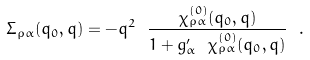Convert formula to latex. <formula><loc_0><loc_0><loc_500><loc_500>\Sigma _ { \rho \alpha } ( q _ { 0 } , q ) = - q ^ { 2 } \ \frac { \chi _ { \rho \alpha } ^ { ( 0 ) } ( q _ { 0 } , q ) } { 1 + g ^ { \prime } _ { \alpha } \ \chi _ { \rho \alpha } ^ { ( 0 ) } ( q _ { 0 } , q ) } \ .</formula> 